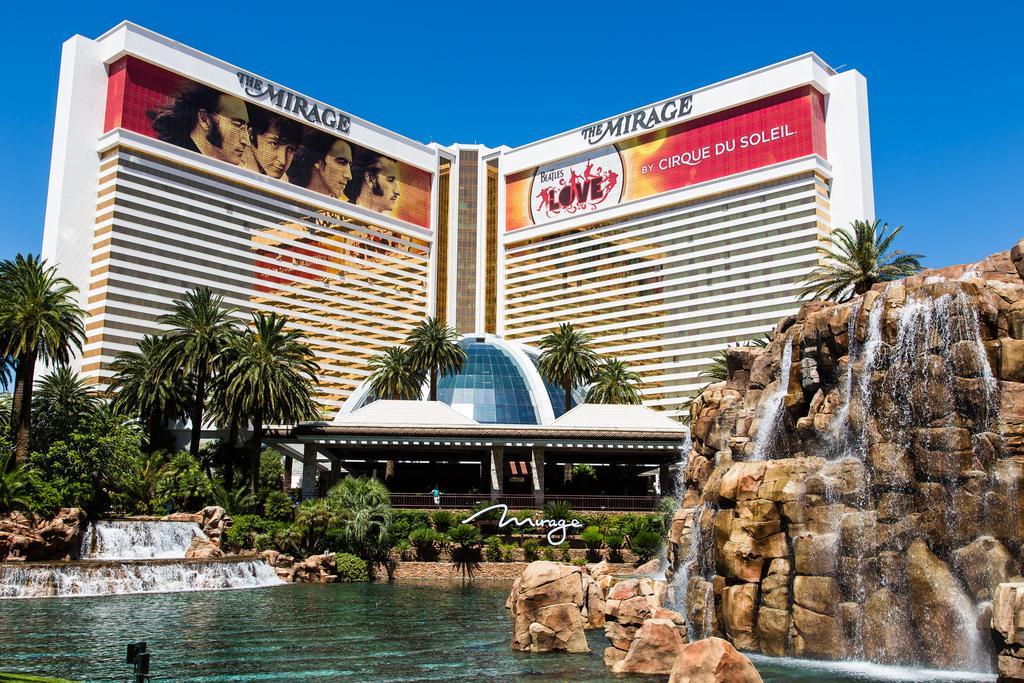Can you describe this image briefly? On the left side, there is water. On the right side, there is a waterfall from a hill and there are rocks partially in the water. In the background, there are trees, buildings, plants and there are clouds in the blue sky. 